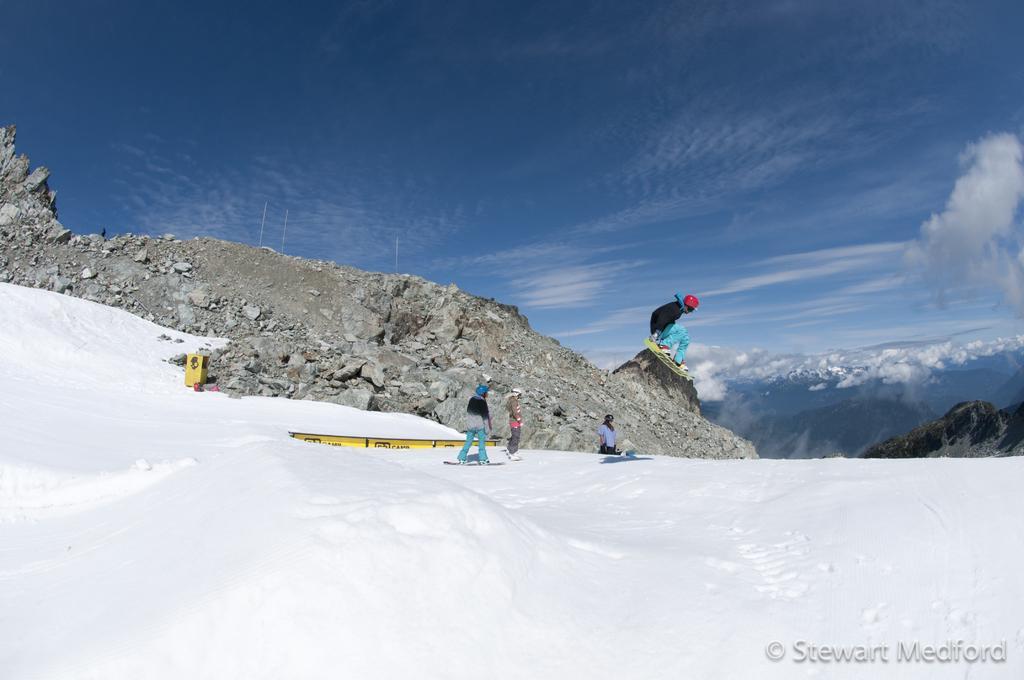Describe this image in one or two sentences. In this image i can see a few persons are doing skating on the snow mountain and on the right side of the image we have a blue sky. 